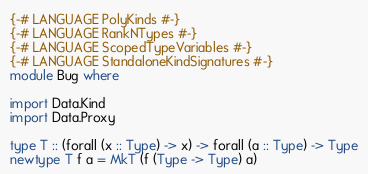Convert code to text. <code><loc_0><loc_0><loc_500><loc_500><_Haskell_>{-# LANGUAGE PolyKinds #-}
{-# LANGUAGE RankNTypes #-}
{-# LANGUAGE ScopedTypeVariables #-}
{-# LANGUAGE StandaloneKindSignatures #-}
module Bug where

import Data.Kind
import Data.Proxy

type T :: (forall (x :: Type) -> x) -> forall (a :: Type) -> Type
newtype T f a = MkT (f (Type -> Type) a)
</code> 